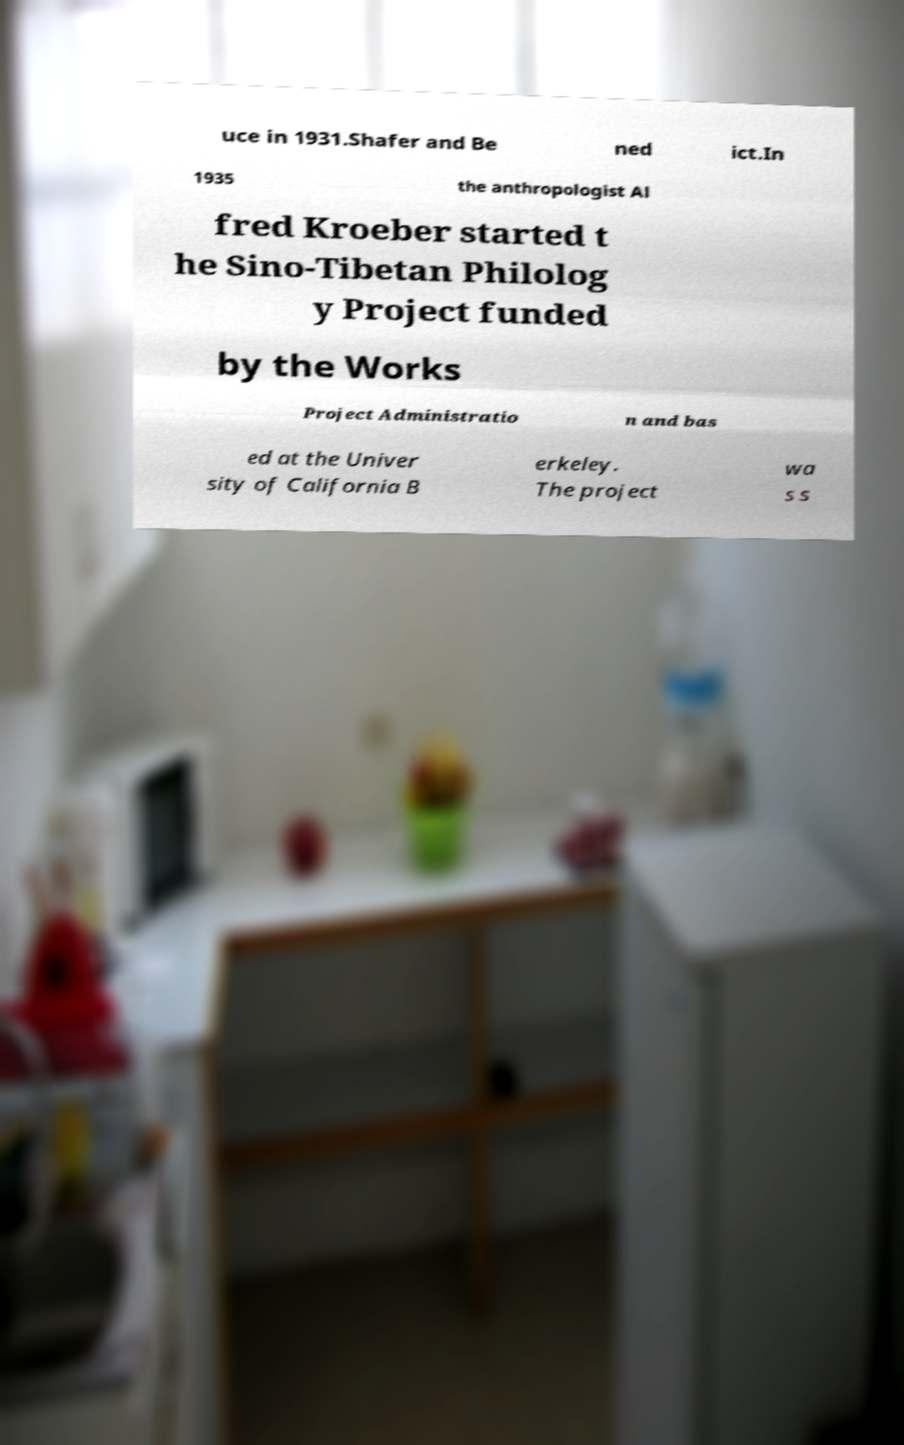There's text embedded in this image that I need extracted. Can you transcribe it verbatim? uce in 1931.Shafer and Be ned ict.In 1935 the anthropologist Al fred Kroeber started t he Sino-Tibetan Philolog y Project funded by the Works Project Administratio n and bas ed at the Univer sity of California B erkeley. The project wa s s 